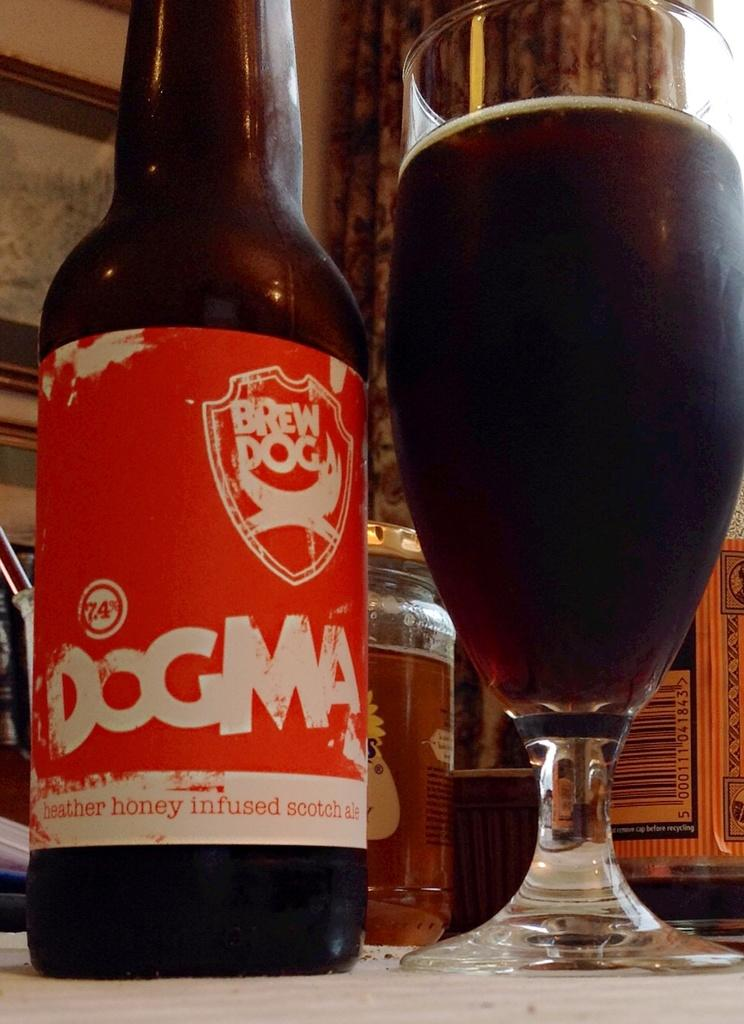<image>
Create a compact narrative representing the image presented. A bottle of Dogma from Brew Dog sits next to a full glass of very dark beer. 